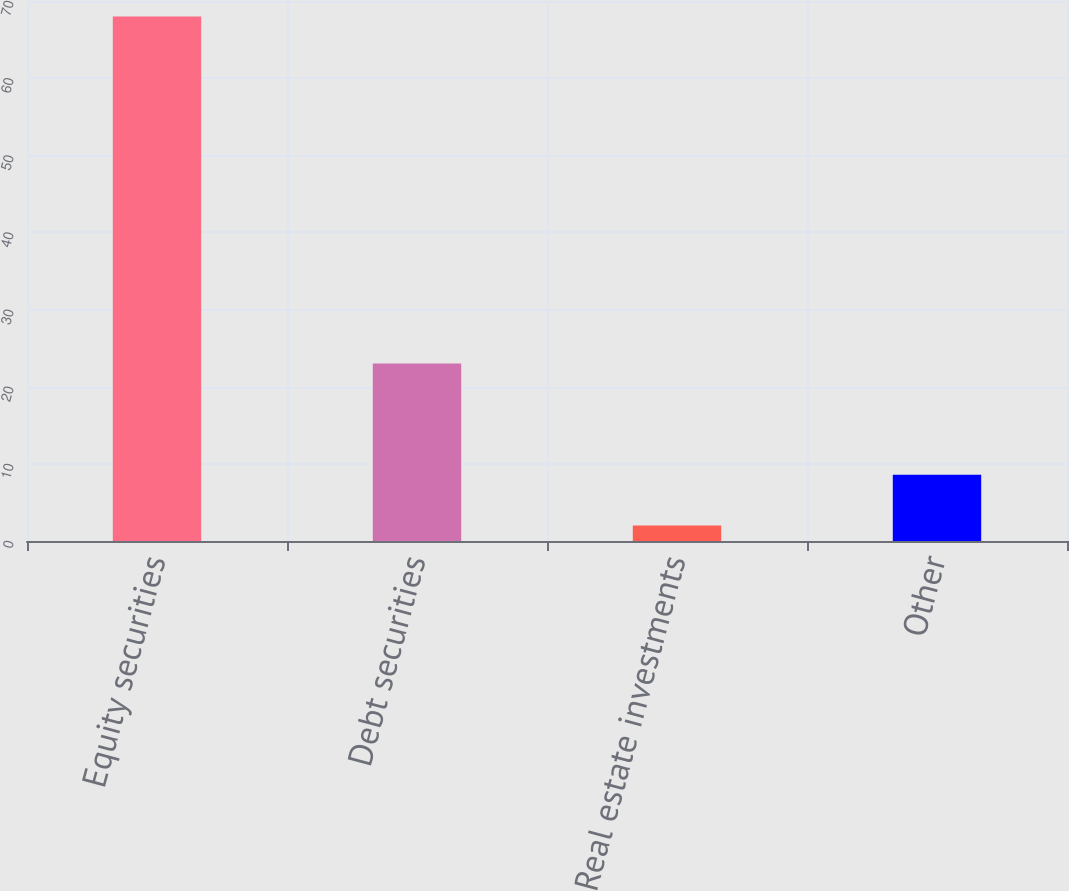Convert chart to OTSL. <chart><loc_0><loc_0><loc_500><loc_500><bar_chart><fcel>Equity securities<fcel>Debt securities<fcel>Real estate investments<fcel>Other<nl><fcel>68<fcel>23<fcel>2<fcel>8.6<nl></chart> 